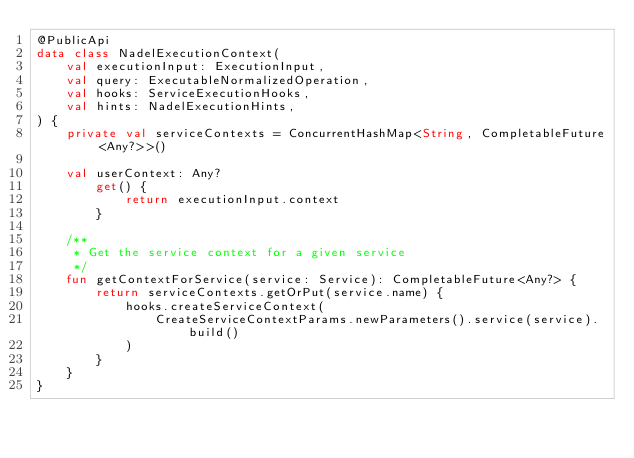<code> <loc_0><loc_0><loc_500><loc_500><_Kotlin_>@PublicApi
data class NadelExecutionContext(
    val executionInput: ExecutionInput,
    val query: ExecutableNormalizedOperation,
    val hooks: ServiceExecutionHooks,
    val hints: NadelExecutionHints,
) {
    private val serviceContexts = ConcurrentHashMap<String, CompletableFuture<Any?>>()

    val userContext: Any?
        get() {
            return executionInput.context
        }

    /**
     * Get the service context for a given service
     */
    fun getContextForService(service: Service): CompletableFuture<Any?> {
        return serviceContexts.getOrPut(service.name) {
            hooks.createServiceContext(
                CreateServiceContextParams.newParameters().service(service).build()
            )
        }
    }
}
</code> 